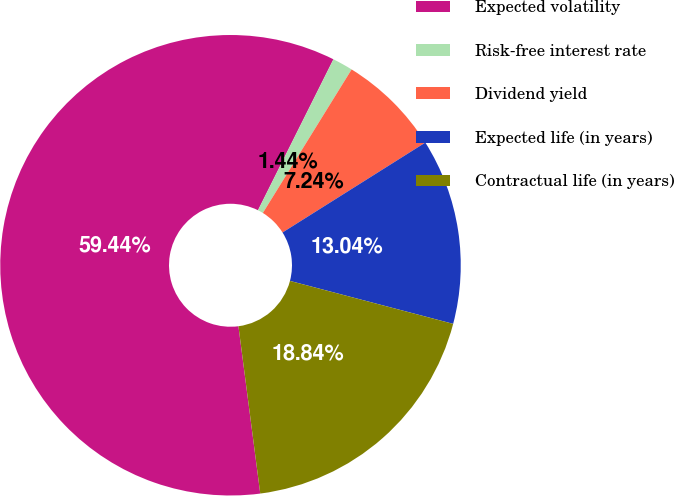<chart> <loc_0><loc_0><loc_500><loc_500><pie_chart><fcel>Expected volatility<fcel>Risk-free interest rate<fcel>Dividend yield<fcel>Expected life (in years)<fcel>Contractual life (in years)<nl><fcel>59.44%<fcel>1.44%<fcel>7.24%<fcel>13.04%<fcel>18.84%<nl></chart> 